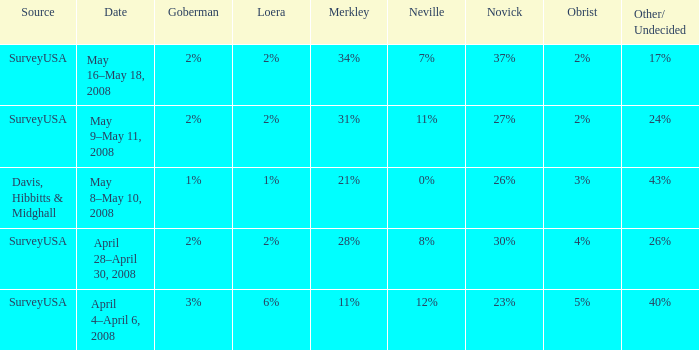Which Date has a Novick of 26%? May 8–May 10, 2008. 